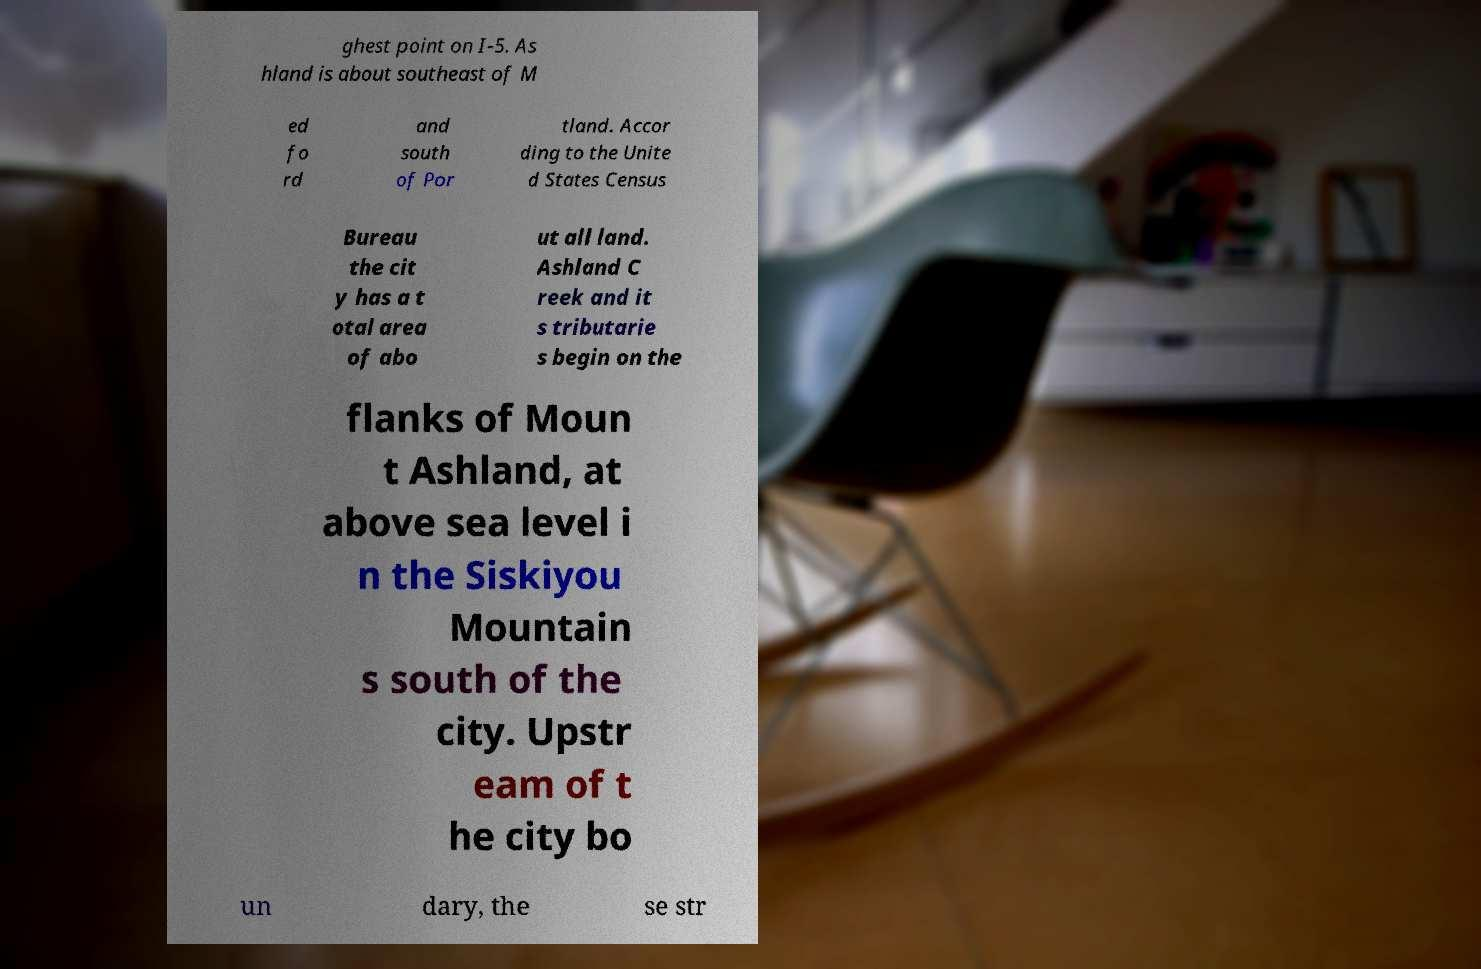Could you extract and type out the text from this image? ghest point on I-5. As hland is about southeast of M ed fo rd and south of Por tland. Accor ding to the Unite d States Census Bureau the cit y has a t otal area of abo ut all land. Ashland C reek and it s tributarie s begin on the flanks of Moun t Ashland, at above sea level i n the Siskiyou Mountain s south of the city. Upstr eam of t he city bo un dary, the se str 